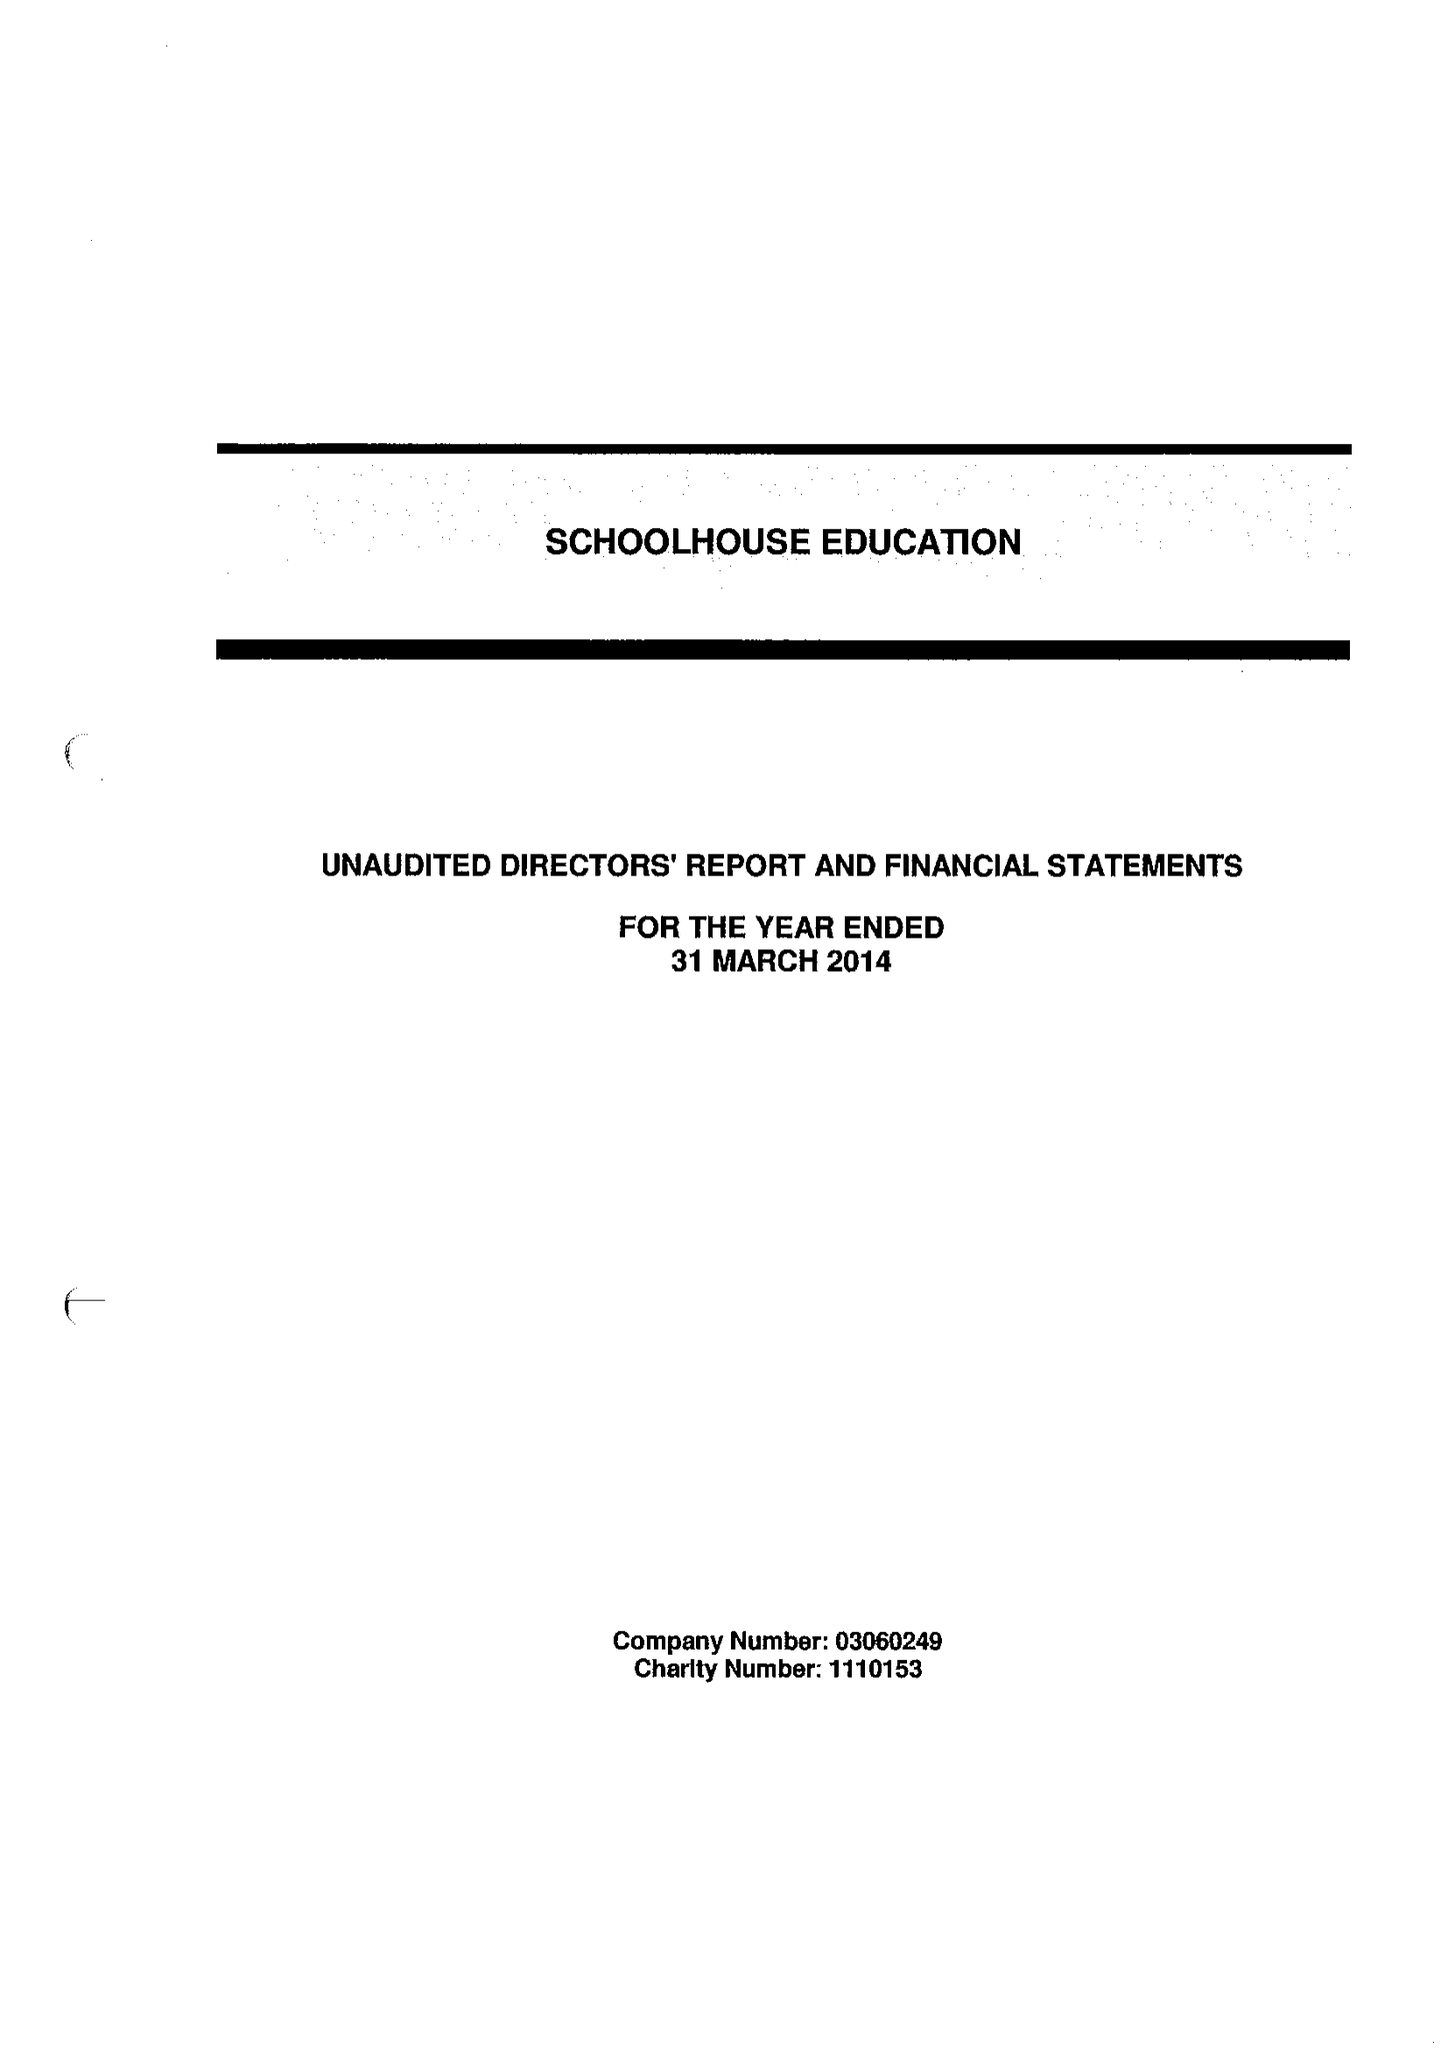What is the value for the address__street_line?
Answer the question using a single word or phrase. 42 COMBWELL CRESCENT 